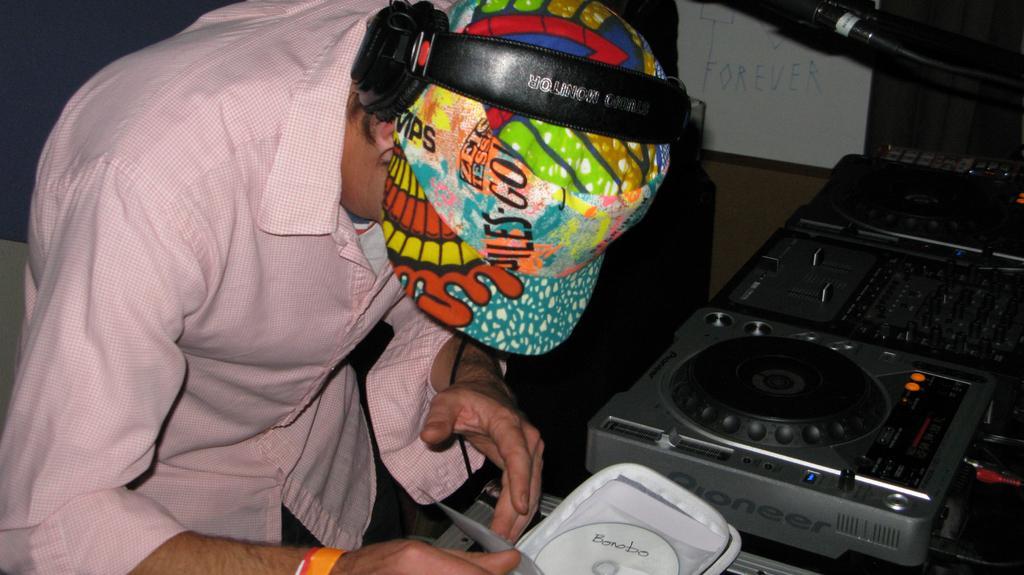Could you give a brief overview of what you see in this image? In this image we can see a person with headphones and cap is holding a bag and there is a CD in the bag, there is a music player, a white board with text and a dark background. 